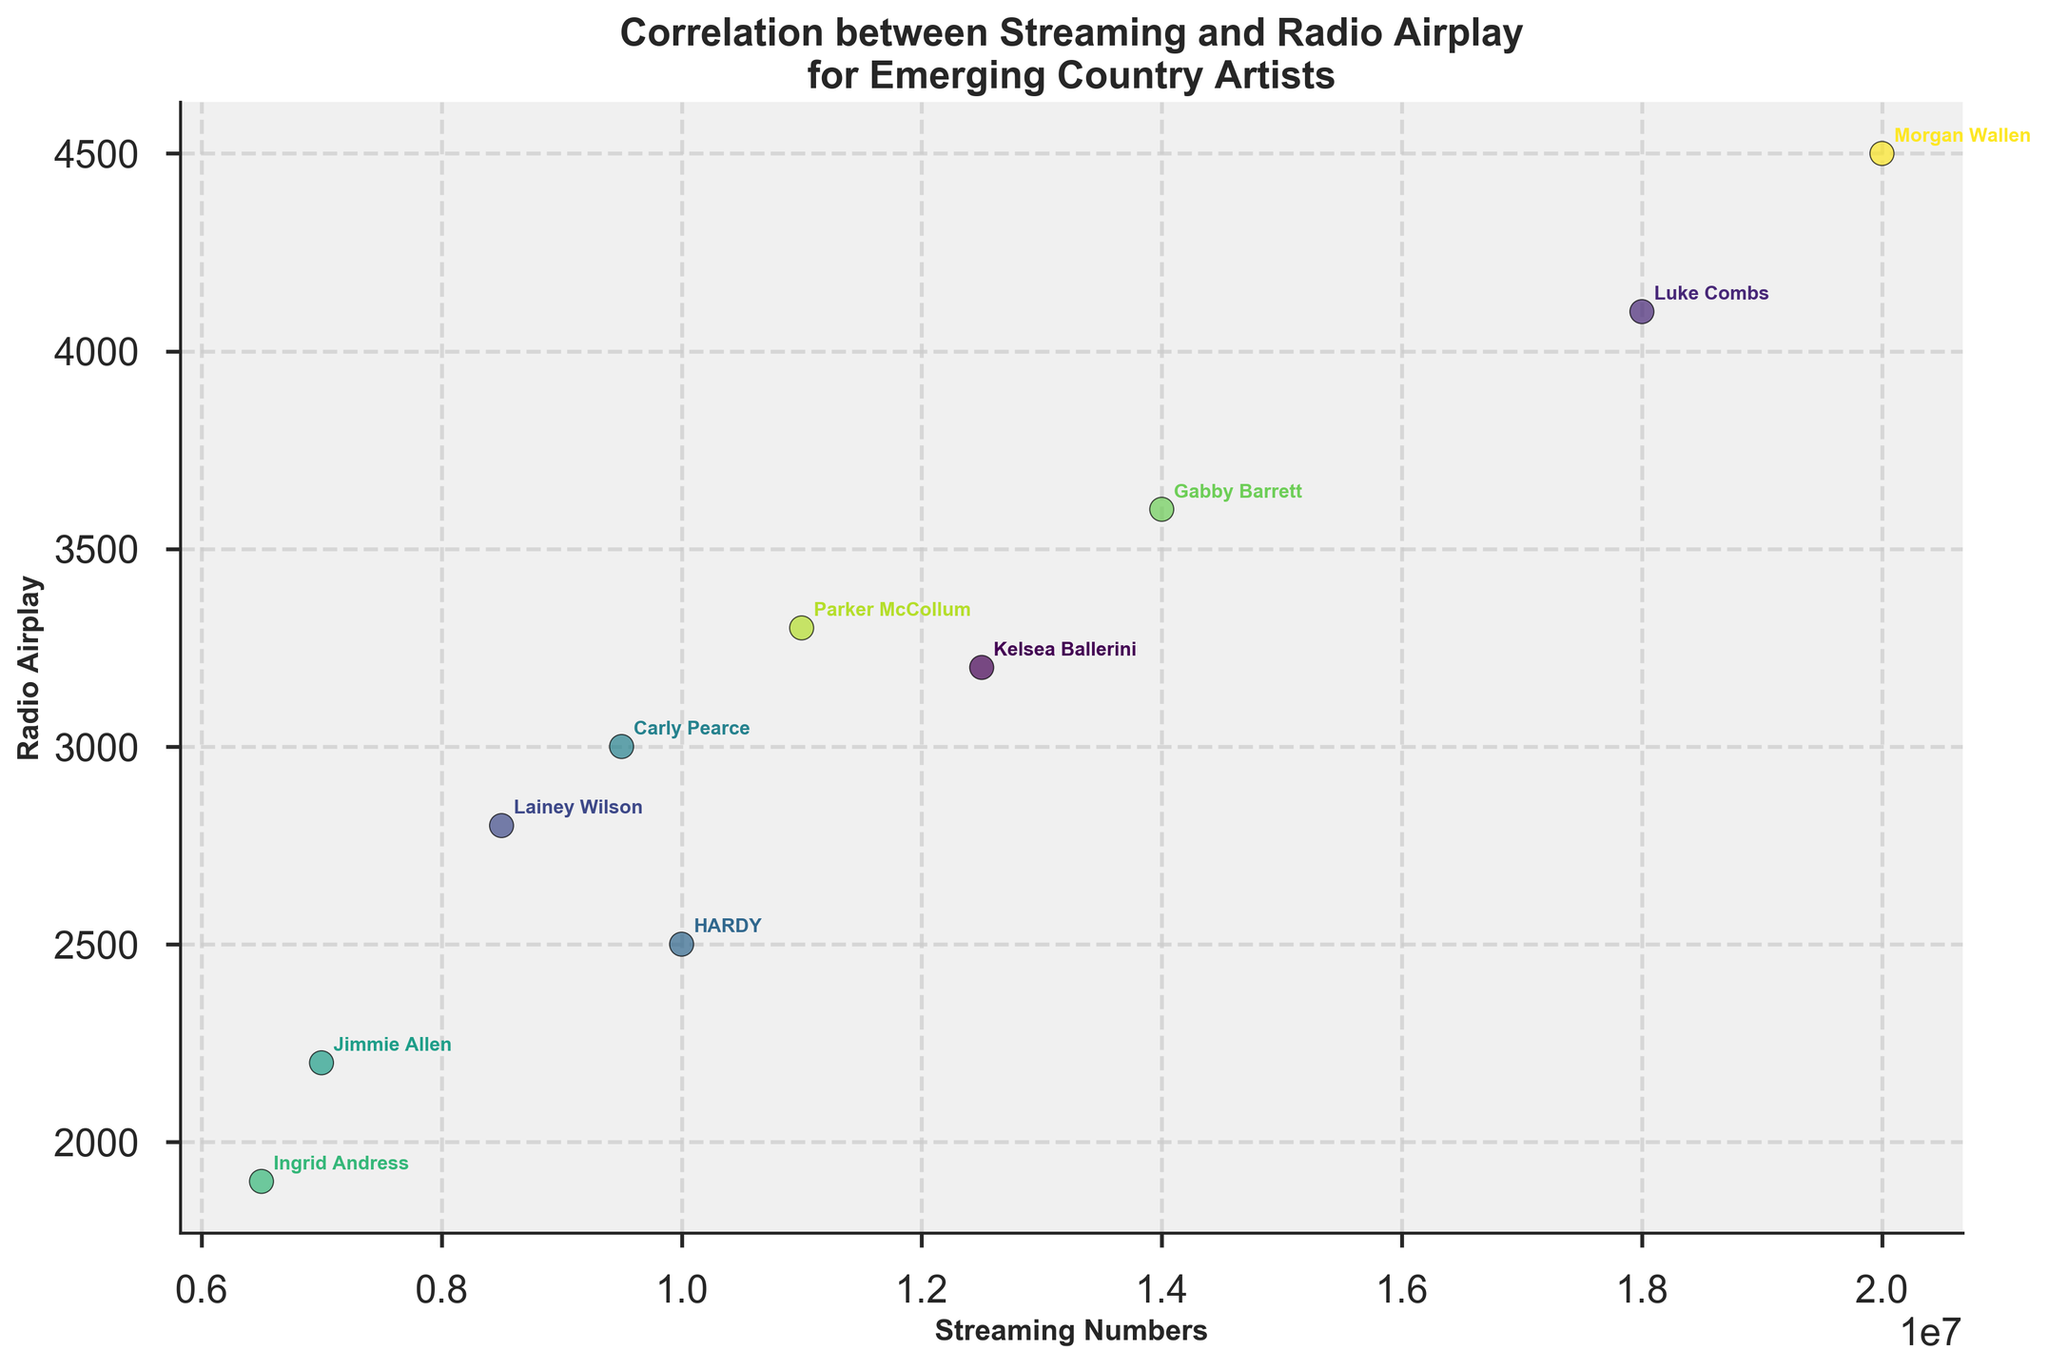What's the title of the plot? The title of the plot is typically placed at the top of the figure. In this case, it reads 'Correlation between Streaming and Radio Airplay for Emerging Country Artists'.
Answer: Correlation between Streaming and Radio Airplay for Emerging Country Artists How many data points are plotted in the figure? The number of data points corresponds to the number of artists shown in the plot. By counting the annotated names, we can identify the number of data points.
Answer: 10 Which artist has the highest streaming numbers? To find this, look at the x-axis for the highest value and find the corresponding annotated artist. In this case, the highest streaming number is 20,000,000.
Answer: Morgan Wallen What is the difference in streaming numbers between Gabby Barrett and HARDY? Gabby Barrett has 14,000,000 streaming numbers while HARDY has 10,000,000. Subtracting HARDY's number from Gabby Barrett's gives us 4,000,000.
Answer: 4,000,000 Which artists have streaming numbers above 15,000,000? Streaming numbers above 15,000,000 would correspond to values on the x-axis higher than this threshold. Morgan Wallen (20,000,000) and Luke Combs (18,000,000) meet this criterion.
Answer: Morgan Wallen, Luke Combs Which artist has the lowest radio airplay, and what is that value? To determine this, look at the y-axis for the smallest value and find the corresponding annotated artist. Ingrid Andress has the lowest radio airplay at 1,900.
Answer: Ingrid Andress, 1,900 What is the average radio airplay value for all artists? Sum up all the radio airplay values: 3200 + 4100 + 2800 + 2500 + 3000 + 2200 + 1900 + 3600 + 3300 + 4500 = 32,100. Divide by the number of artists, which is 10. Average = 32,100 / 10 = 3,210.
Answer: 3,210 Compare the streaming numbers of Lainey Wilson and Parker McCollum. Which artist has higher streaming numbers? Lainey Wilson has 8,500,000 streaming numbers, and Parker McCollum has 11,000,000. Therefore, Parker McCollum has higher streaming numbers.
Answer: Parker McCollum Is there a positive correlation between streaming numbers and radio airplay? To determine correlation, observe whether higher streaming numbers tend to align with higher radio airplay values. The plot shows this positive trend.
Answer: Yes Considering Carly Pearce and Kelsea Ballerini, who has higher radio airplay and by how much? Carly Pearce has 3,000 radio airplay, while Kelsea Ballerini has 3,200. The difference is 3,200 - 3,000 = 200.
Answer: Kelsea Ballerini, 200 